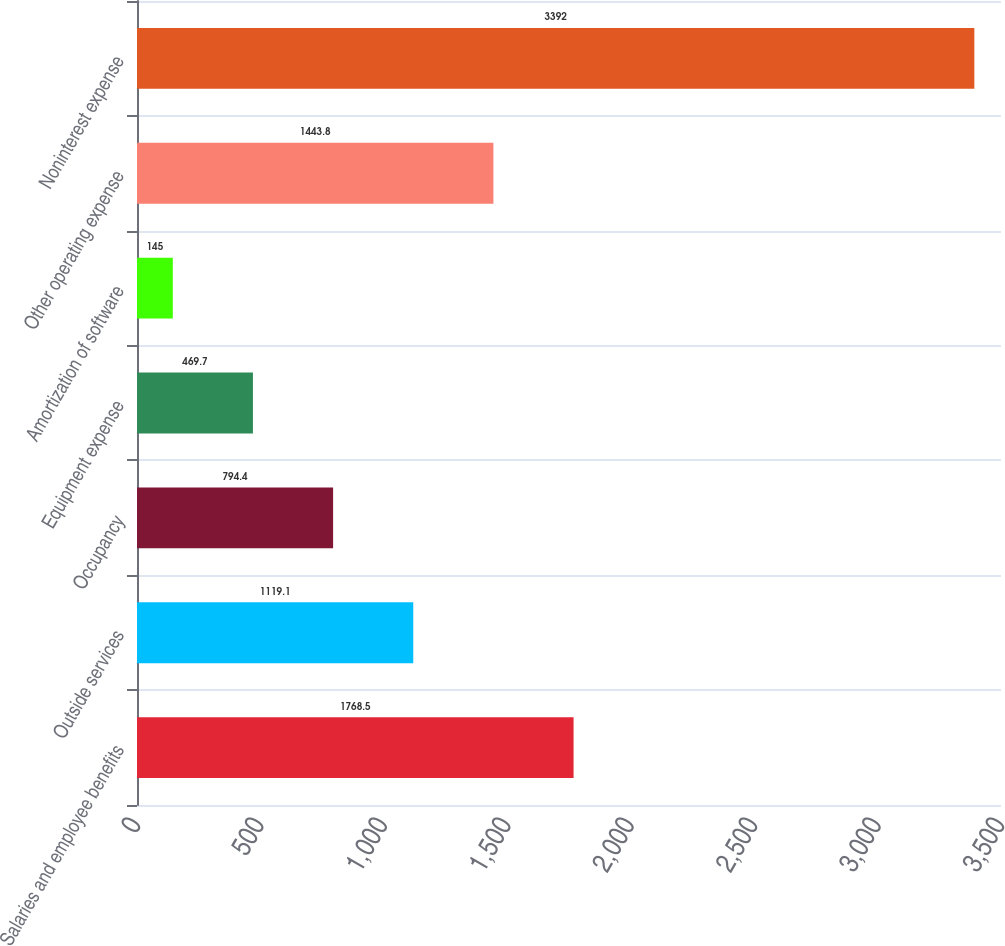Convert chart to OTSL. <chart><loc_0><loc_0><loc_500><loc_500><bar_chart><fcel>Salaries and employee benefits<fcel>Outside services<fcel>Occupancy<fcel>Equipment expense<fcel>Amortization of software<fcel>Other operating expense<fcel>Noninterest expense<nl><fcel>1768.5<fcel>1119.1<fcel>794.4<fcel>469.7<fcel>145<fcel>1443.8<fcel>3392<nl></chart> 